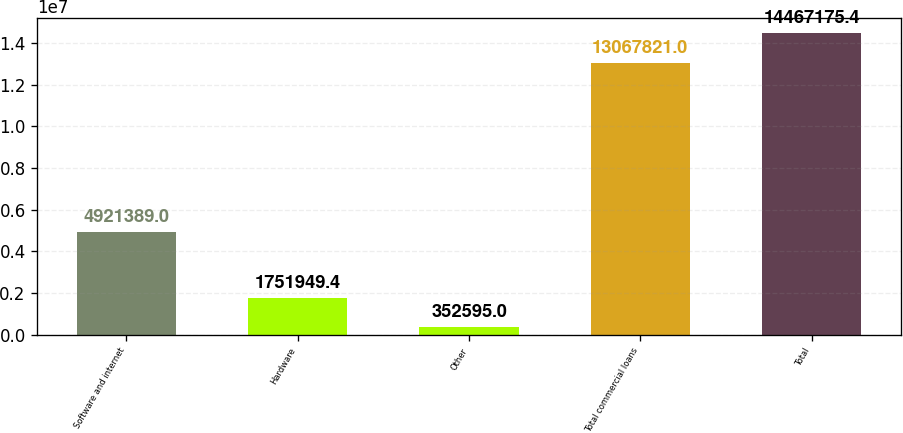<chart> <loc_0><loc_0><loc_500><loc_500><bar_chart><fcel>Software and internet<fcel>Hardware<fcel>Other<fcel>Total commercial loans<fcel>Total<nl><fcel>4.92139e+06<fcel>1.75195e+06<fcel>352595<fcel>1.30678e+07<fcel>1.44672e+07<nl></chart> 